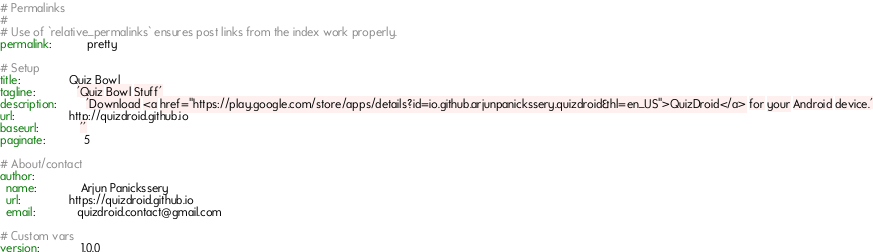Convert code to text. <code><loc_0><loc_0><loc_500><loc_500><_YAML_># Permalinks
#
# Use of `relative_permalinks` ensures post links from the index work properly.
permalink:           pretty

# Setup
title:               Quiz Bowl
tagline:             'Quiz Bowl Stuff'
description:         'Download <a href="https://play.google.com/store/apps/details?id=io.github.arjunpanickssery.quizdroid&hl=en_US">QuizDroid</a> for your Android device.'
url:                 http://quizdroid.github.io
baseurl:             ''
paginate:            5

# About/contact
author:
  name:              Arjun Panickssery
  url:               https://quizdroid.github.io
  email:             quizdroid.contact@gmail.com

# Custom vars
version:             1.0.0
</code> 